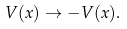Convert formula to latex. <formula><loc_0><loc_0><loc_500><loc_500>V ( x ) \rightarrow - V ( x ) .</formula> 